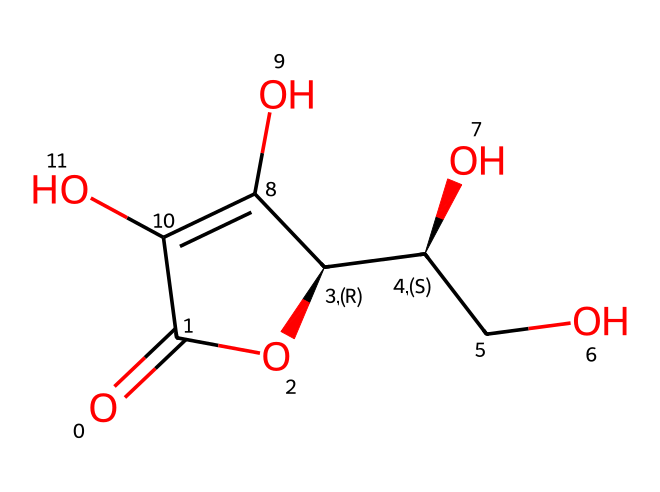What is the molecular formula of this vitamin C structure? To find the molecular formula, we count the types and numbers of atoms in the SMILES representation. From the structure, we can identify 6 carbons (C), 8 hydrogens (H), 6 oxygens (O), leading to the molecular formula C6H8O6.
Answer: C6H8O6 How many chiral centers are present in this chemical structure? A chiral center is typically identified by a carbon atom bonded to four different groups. Analyzing the structure, there are two carbon atoms (C) that meet this criterion, indicating that there are 2 chiral centers.
Answer: 2 What type of chemical compound is vitamin C classified as? Vitamin C is classified based on its functionality and properties. Given its structure consisting of a lactone (cyclic ester) and multiple hydroxyl (OH) groups, it is classified as an organic compound, specifically a vitamin.
Answer: vitamin Which part of this chemical structure contributes to its acidity? The presence of the carboxyl group (–COOH) defines the acidic behavior of this compound. In this structure, the carbonyl (C=O) is responsible for contributing to acidity.
Answer: carbonyl How many hydroxyl groups (–OH) are present in this molecule? To determine the number of hydroxyl groups, we look for any attached (–OH) functionalities. In the displayed structure, there are four hydroxyl groups present, which can be counted directly.
Answer: 4 What functional group is responsible for the antioxidant properties of this vitamin? The property of being an antioxidant is primarily due to the presence of the enediol structure (the arrangement of hydroxyls and double bonds), particularly seen in the specific arrangement of -OH groups adjacent to double bonds in vitamin C.
Answer: enediol 